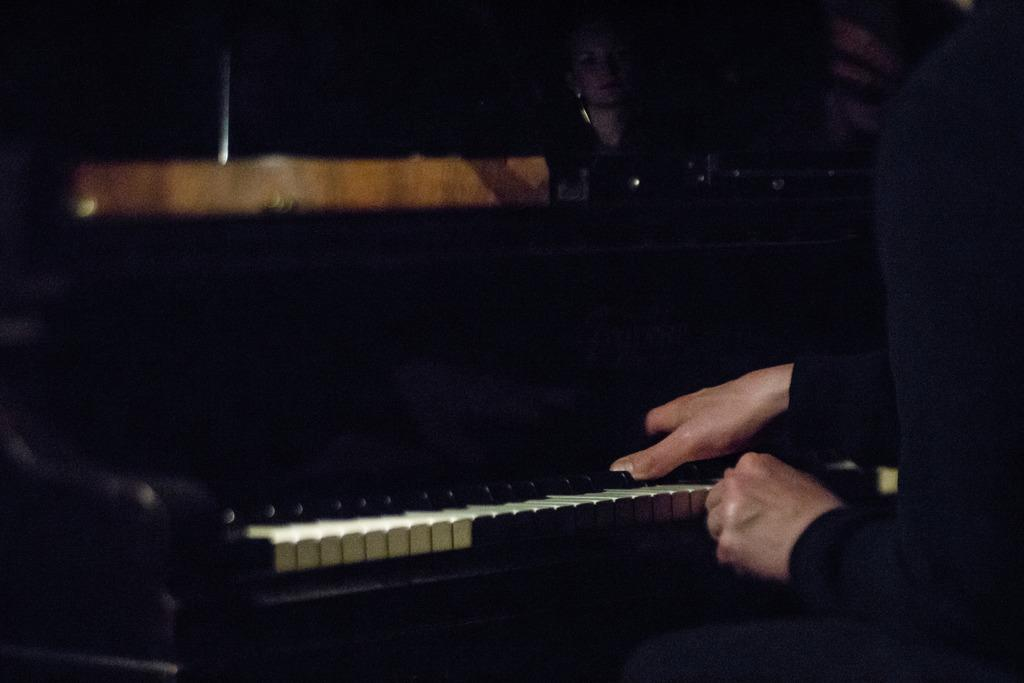What musical instrument is present in the image? There is a piano in the image. What colors can be seen on the piano? The piano is white and black in color. What is the person in the image doing? The person is sitting and playing the piano. How does the person's anger affect the sound of the piano in the image? There is no indication of the person's anger in the image, and therefore it cannot be determined how it might affect the sound of the piano. 